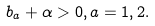<formula> <loc_0><loc_0><loc_500><loc_500>b _ { a } + \alpha > 0 , a = 1 , 2 .</formula> 